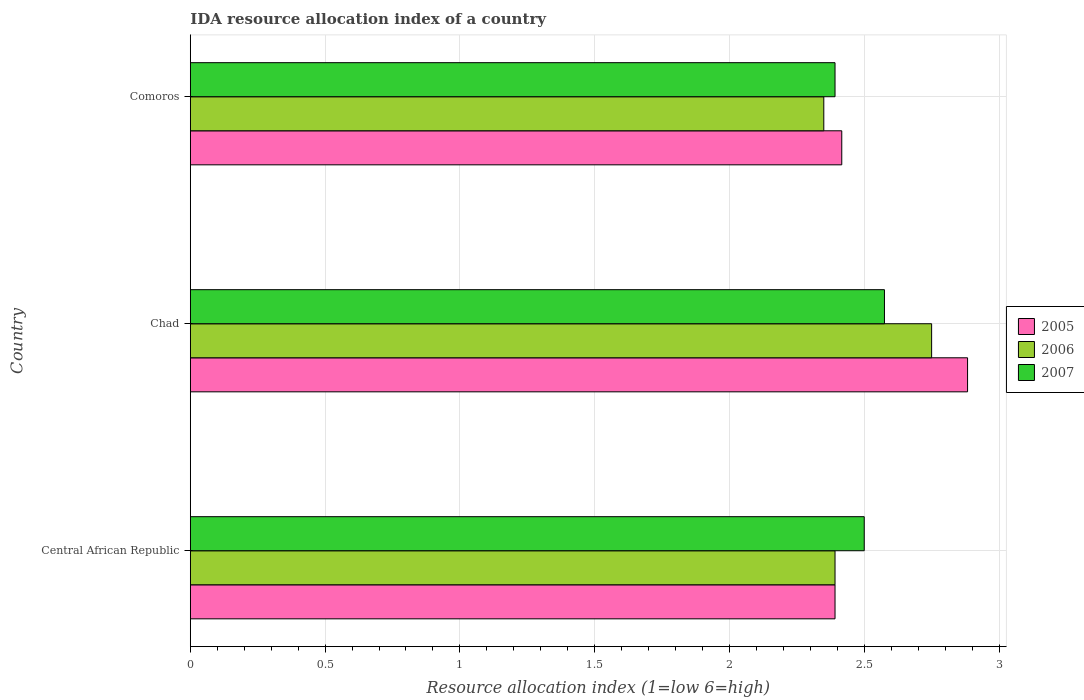How many different coloured bars are there?
Offer a very short reply. 3. How many groups of bars are there?
Provide a succinct answer. 3. How many bars are there on the 3rd tick from the bottom?
Your response must be concise. 3. What is the label of the 1st group of bars from the top?
Provide a short and direct response. Comoros. In how many cases, is the number of bars for a given country not equal to the number of legend labels?
Your answer should be compact. 0. Across all countries, what is the maximum IDA resource allocation index in 2005?
Your response must be concise. 2.88. Across all countries, what is the minimum IDA resource allocation index in 2006?
Provide a succinct answer. 2.35. In which country was the IDA resource allocation index in 2005 maximum?
Provide a succinct answer. Chad. In which country was the IDA resource allocation index in 2005 minimum?
Your answer should be compact. Central African Republic. What is the total IDA resource allocation index in 2007 in the graph?
Provide a short and direct response. 7.47. What is the difference between the IDA resource allocation index in 2007 in Central African Republic and that in Chad?
Keep it short and to the point. -0.08. What is the difference between the IDA resource allocation index in 2005 in Central African Republic and the IDA resource allocation index in 2007 in Chad?
Keep it short and to the point. -0.18. What is the average IDA resource allocation index in 2006 per country?
Your answer should be compact. 2.5. What is the difference between the IDA resource allocation index in 2006 and IDA resource allocation index in 2007 in Chad?
Your answer should be very brief. 0.17. In how many countries, is the IDA resource allocation index in 2007 greater than 0.30000000000000004 ?
Give a very brief answer. 3. What is the ratio of the IDA resource allocation index in 2005 in Central African Republic to that in Chad?
Keep it short and to the point. 0.83. What is the difference between the highest and the second highest IDA resource allocation index in 2005?
Offer a terse response. 0.47. What is the difference between the highest and the lowest IDA resource allocation index in 2007?
Offer a very short reply. 0.18. In how many countries, is the IDA resource allocation index in 2007 greater than the average IDA resource allocation index in 2007 taken over all countries?
Keep it short and to the point. 2. Is the sum of the IDA resource allocation index in 2006 in Central African Republic and Comoros greater than the maximum IDA resource allocation index in 2005 across all countries?
Keep it short and to the point. Yes. What does the 1st bar from the top in Chad represents?
Your answer should be compact. 2007. Does the graph contain any zero values?
Provide a short and direct response. No. Does the graph contain grids?
Your answer should be very brief. Yes. What is the title of the graph?
Provide a short and direct response. IDA resource allocation index of a country. What is the label or title of the X-axis?
Your answer should be compact. Resource allocation index (1=low 6=high). What is the label or title of the Y-axis?
Your answer should be very brief. Country. What is the Resource allocation index (1=low 6=high) in 2005 in Central African Republic?
Offer a terse response. 2.39. What is the Resource allocation index (1=low 6=high) in 2006 in Central African Republic?
Keep it short and to the point. 2.39. What is the Resource allocation index (1=low 6=high) of 2007 in Central African Republic?
Keep it short and to the point. 2.5. What is the Resource allocation index (1=low 6=high) in 2005 in Chad?
Make the answer very short. 2.88. What is the Resource allocation index (1=low 6=high) of 2006 in Chad?
Your answer should be compact. 2.75. What is the Resource allocation index (1=low 6=high) of 2007 in Chad?
Keep it short and to the point. 2.58. What is the Resource allocation index (1=low 6=high) in 2005 in Comoros?
Ensure brevity in your answer.  2.42. What is the Resource allocation index (1=low 6=high) of 2006 in Comoros?
Give a very brief answer. 2.35. What is the Resource allocation index (1=low 6=high) in 2007 in Comoros?
Ensure brevity in your answer.  2.39. Across all countries, what is the maximum Resource allocation index (1=low 6=high) in 2005?
Offer a terse response. 2.88. Across all countries, what is the maximum Resource allocation index (1=low 6=high) in 2006?
Keep it short and to the point. 2.75. Across all countries, what is the maximum Resource allocation index (1=low 6=high) of 2007?
Your response must be concise. 2.58. Across all countries, what is the minimum Resource allocation index (1=low 6=high) of 2005?
Ensure brevity in your answer.  2.39. Across all countries, what is the minimum Resource allocation index (1=low 6=high) of 2006?
Your answer should be very brief. 2.35. Across all countries, what is the minimum Resource allocation index (1=low 6=high) in 2007?
Your response must be concise. 2.39. What is the total Resource allocation index (1=low 6=high) in 2005 in the graph?
Offer a terse response. 7.69. What is the total Resource allocation index (1=low 6=high) of 2006 in the graph?
Offer a terse response. 7.49. What is the total Resource allocation index (1=low 6=high) of 2007 in the graph?
Offer a terse response. 7.47. What is the difference between the Resource allocation index (1=low 6=high) in 2005 in Central African Republic and that in Chad?
Give a very brief answer. -0.49. What is the difference between the Resource allocation index (1=low 6=high) in 2006 in Central African Republic and that in Chad?
Provide a succinct answer. -0.36. What is the difference between the Resource allocation index (1=low 6=high) of 2007 in Central African Republic and that in Chad?
Provide a short and direct response. -0.07. What is the difference between the Resource allocation index (1=low 6=high) in 2005 in Central African Republic and that in Comoros?
Your answer should be very brief. -0.03. What is the difference between the Resource allocation index (1=low 6=high) of 2006 in Central African Republic and that in Comoros?
Keep it short and to the point. 0.04. What is the difference between the Resource allocation index (1=low 6=high) in 2007 in Central African Republic and that in Comoros?
Give a very brief answer. 0.11. What is the difference between the Resource allocation index (1=low 6=high) in 2005 in Chad and that in Comoros?
Keep it short and to the point. 0.47. What is the difference between the Resource allocation index (1=low 6=high) in 2006 in Chad and that in Comoros?
Your answer should be compact. 0.4. What is the difference between the Resource allocation index (1=low 6=high) in 2007 in Chad and that in Comoros?
Offer a very short reply. 0.18. What is the difference between the Resource allocation index (1=low 6=high) of 2005 in Central African Republic and the Resource allocation index (1=low 6=high) of 2006 in Chad?
Your answer should be compact. -0.36. What is the difference between the Resource allocation index (1=low 6=high) in 2005 in Central African Republic and the Resource allocation index (1=low 6=high) in 2007 in Chad?
Your answer should be compact. -0.18. What is the difference between the Resource allocation index (1=low 6=high) of 2006 in Central African Republic and the Resource allocation index (1=low 6=high) of 2007 in Chad?
Provide a succinct answer. -0.18. What is the difference between the Resource allocation index (1=low 6=high) of 2005 in Central African Republic and the Resource allocation index (1=low 6=high) of 2006 in Comoros?
Offer a terse response. 0.04. What is the difference between the Resource allocation index (1=low 6=high) of 2005 in Central African Republic and the Resource allocation index (1=low 6=high) of 2007 in Comoros?
Ensure brevity in your answer.  0. What is the difference between the Resource allocation index (1=low 6=high) of 2005 in Chad and the Resource allocation index (1=low 6=high) of 2006 in Comoros?
Your response must be concise. 0.53. What is the difference between the Resource allocation index (1=low 6=high) in 2005 in Chad and the Resource allocation index (1=low 6=high) in 2007 in Comoros?
Offer a very short reply. 0.49. What is the difference between the Resource allocation index (1=low 6=high) in 2006 in Chad and the Resource allocation index (1=low 6=high) in 2007 in Comoros?
Make the answer very short. 0.36. What is the average Resource allocation index (1=low 6=high) in 2005 per country?
Provide a succinct answer. 2.56. What is the average Resource allocation index (1=low 6=high) of 2006 per country?
Provide a short and direct response. 2.5. What is the average Resource allocation index (1=low 6=high) of 2007 per country?
Offer a very short reply. 2.49. What is the difference between the Resource allocation index (1=low 6=high) in 2005 and Resource allocation index (1=low 6=high) in 2006 in Central African Republic?
Keep it short and to the point. 0. What is the difference between the Resource allocation index (1=low 6=high) of 2005 and Resource allocation index (1=low 6=high) of 2007 in Central African Republic?
Give a very brief answer. -0.11. What is the difference between the Resource allocation index (1=low 6=high) in 2006 and Resource allocation index (1=low 6=high) in 2007 in Central African Republic?
Make the answer very short. -0.11. What is the difference between the Resource allocation index (1=low 6=high) in 2005 and Resource allocation index (1=low 6=high) in 2006 in Chad?
Your answer should be very brief. 0.13. What is the difference between the Resource allocation index (1=low 6=high) of 2005 and Resource allocation index (1=low 6=high) of 2007 in Chad?
Provide a short and direct response. 0.31. What is the difference between the Resource allocation index (1=low 6=high) of 2006 and Resource allocation index (1=low 6=high) of 2007 in Chad?
Your answer should be very brief. 0.17. What is the difference between the Resource allocation index (1=low 6=high) of 2005 and Resource allocation index (1=low 6=high) of 2006 in Comoros?
Give a very brief answer. 0.07. What is the difference between the Resource allocation index (1=low 6=high) in 2005 and Resource allocation index (1=low 6=high) in 2007 in Comoros?
Provide a short and direct response. 0.03. What is the difference between the Resource allocation index (1=low 6=high) of 2006 and Resource allocation index (1=low 6=high) of 2007 in Comoros?
Your answer should be very brief. -0.04. What is the ratio of the Resource allocation index (1=low 6=high) in 2005 in Central African Republic to that in Chad?
Ensure brevity in your answer.  0.83. What is the ratio of the Resource allocation index (1=low 6=high) in 2006 in Central African Republic to that in Chad?
Your answer should be compact. 0.87. What is the ratio of the Resource allocation index (1=low 6=high) in 2007 in Central African Republic to that in Chad?
Offer a very short reply. 0.97. What is the ratio of the Resource allocation index (1=low 6=high) of 2005 in Central African Republic to that in Comoros?
Your answer should be very brief. 0.99. What is the ratio of the Resource allocation index (1=low 6=high) in 2006 in Central African Republic to that in Comoros?
Offer a terse response. 1.02. What is the ratio of the Resource allocation index (1=low 6=high) in 2007 in Central African Republic to that in Comoros?
Ensure brevity in your answer.  1.05. What is the ratio of the Resource allocation index (1=low 6=high) in 2005 in Chad to that in Comoros?
Keep it short and to the point. 1.19. What is the ratio of the Resource allocation index (1=low 6=high) in 2006 in Chad to that in Comoros?
Your answer should be compact. 1.17. What is the ratio of the Resource allocation index (1=low 6=high) in 2007 in Chad to that in Comoros?
Make the answer very short. 1.08. What is the difference between the highest and the second highest Resource allocation index (1=low 6=high) of 2005?
Provide a succinct answer. 0.47. What is the difference between the highest and the second highest Resource allocation index (1=low 6=high) in 2006?
Make the answer very short. 0.36. What is the difference between the highest and the second highest Resource allocation index (1=low 6=high) in 2007?
Provide a succinct answer. 0.07. What is the difference between the highest and the lowest Resource allocation index (1=low 6=high) in 2005?
Offer a terse response. 0.49. What is the difference between the highest and the lowest Resource allocation index (1=low 6=high) in 2006?
Provide a succinct answer. 0.4. What is the difference between the highest and the lowest Resource allocation index (1=low 6=high) of 2007?
Provide a short and direct response. 0.18. 